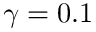Convert formula to latex. <formula><loc_0><loc_0><loc_500><loc_500>\gamma = 0 . 1</formula> 